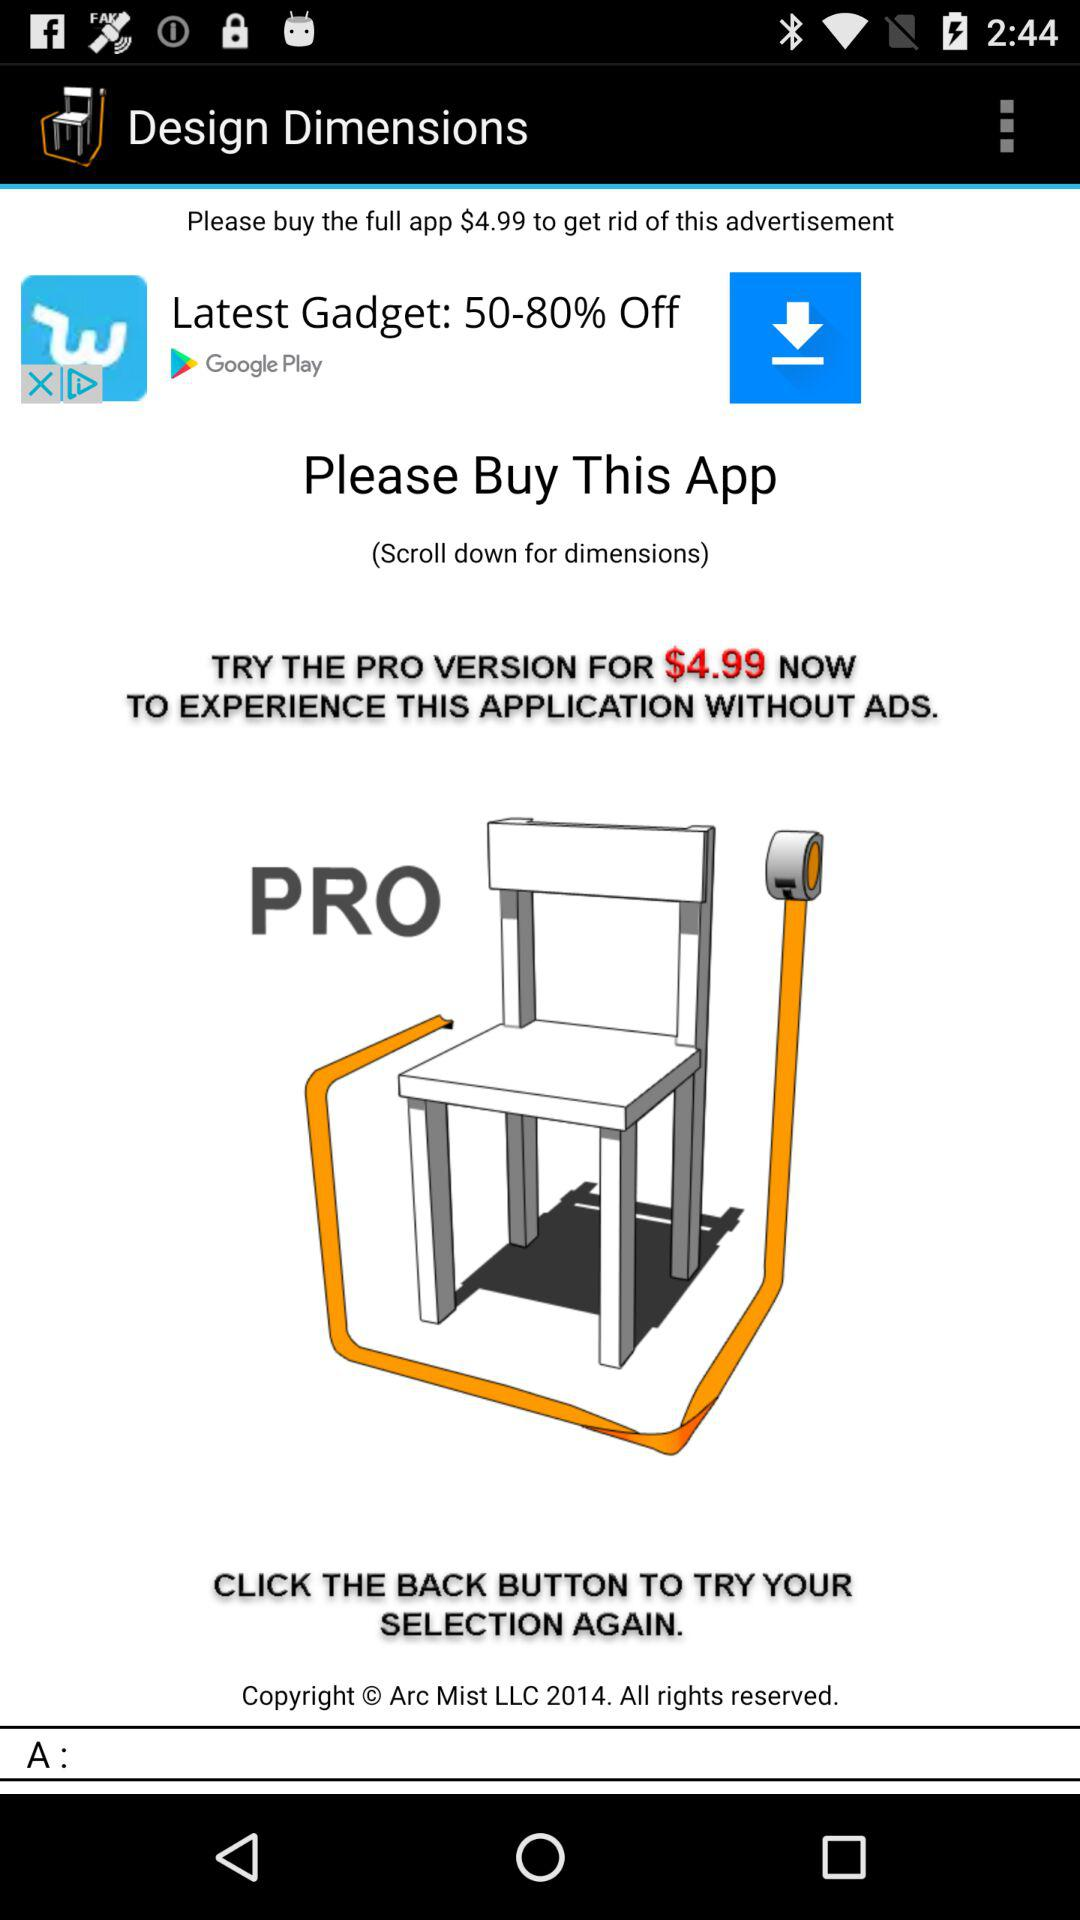What is the application name? The application name is "Design Dimensions". 